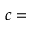Convert formula to latex. <formula><loc_0><loc_0><loc_500><loc_500>c =</formula> 